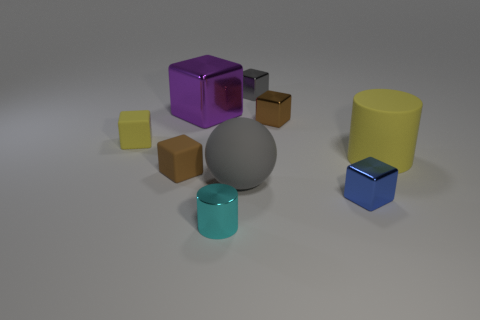Subtract all balls. How many objects are left? 8 Add 1 large brown shiny cylinders. How many objects exist? 10 Subtract all small brown cubes. How many cubes are left? 4 Subtract 1 gray balls. How many objects are left? 8 Subtract 4 cubes. How many cubes are left? 2 Subtract all cyan spheres. Subtract all green blocks. How many spheres are left? 1 Subtract all cyan cylinders. How many cyan balls are left? 0 Subtract all purple objects. Subtract all small rubber cubes. How many objects are left? 6 Add 8 purple metallic things. How many purple metallic things are left? 9 Add 8 small brown rubber blocks. How many small brown rubber blocks exist? 9 